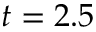Convert formula to latex. <formula><loc_0><loc_0><loc_500><loc_500>t = 2 . 5</formula> 